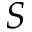Convert formula to latex. <formula><loc_0><loc_0><loc_500><loc_500>S</formula> 